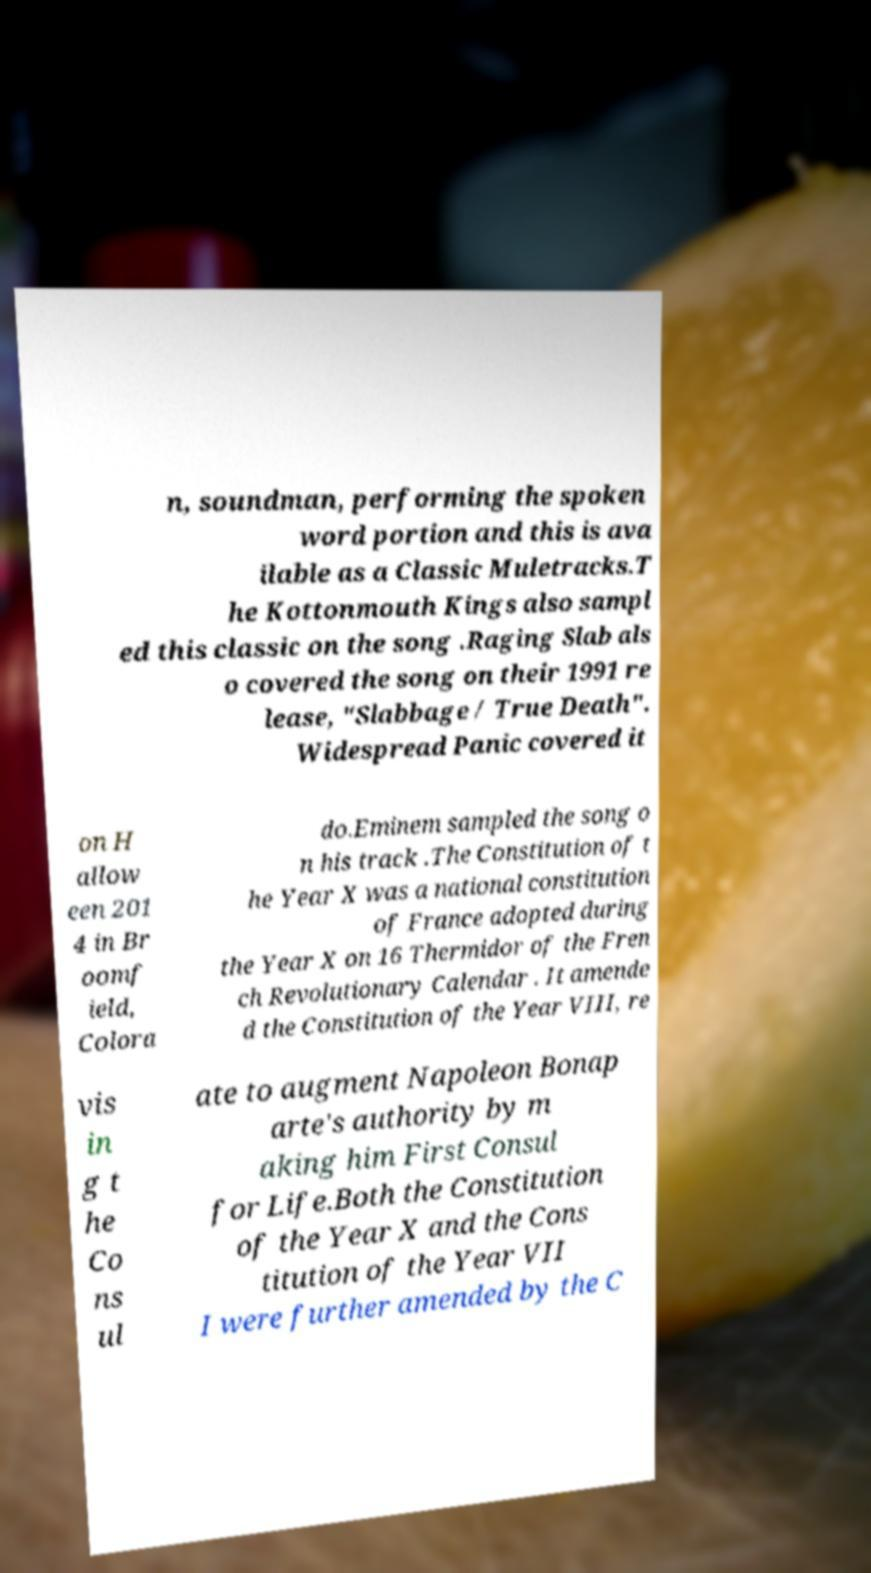For documentation purposes, I need the text within this image transcribed. Could you provide that? n, soundman, performing the spoken word portion and this is ava ilable as a Classic Muletracks.T he Kottonmouth Kings also sampl ed this classic on the song .Raging Slab als o covered the song on their 1991 re lease, "Slabbage / True Death". Widespread Panic covered it on H allow een 201 4 in Br oomf ield, Colora do.Eminem sampled the song o n his track .The Constitution of t he Year X was a national constitution of France adopted during the Year X on 16 Thermidor of the Fren ch Revolutionary Calendar . It amende d the Constitution of the Year VIII, re vis in g t he Co ns ul ate to augment Napoleon Bonap arte's authority by m aking him First Consul for Life.Both the Constitution of the Year X and the Cons titution of the Year VII I were further amended by the C 